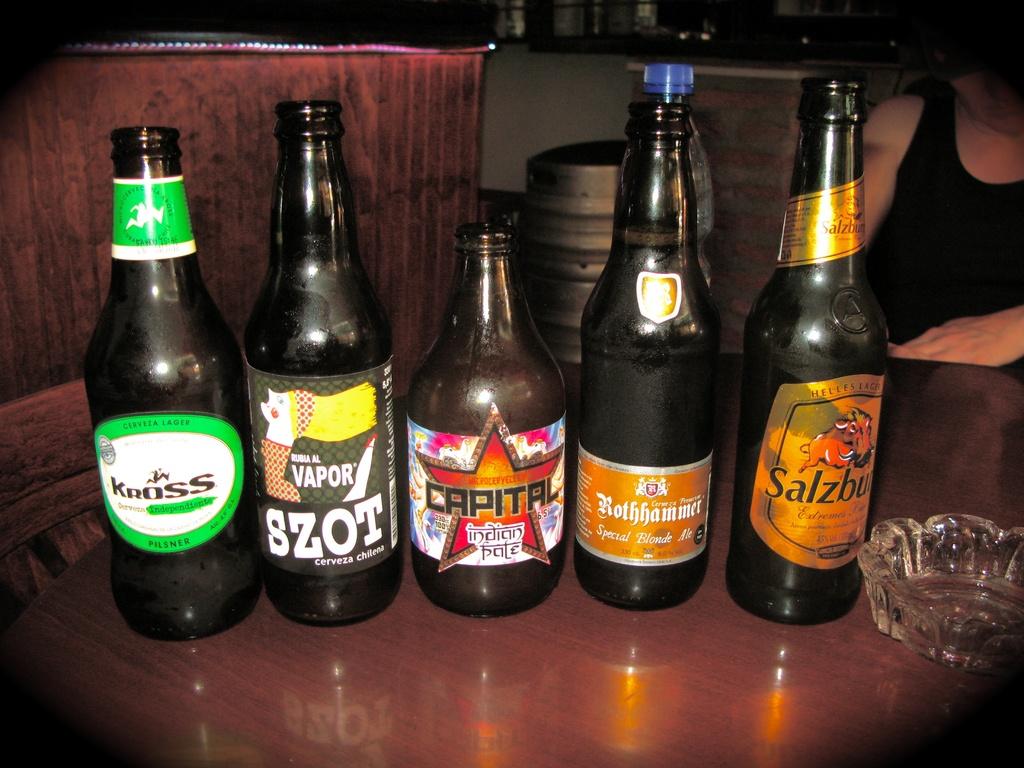What is written on the far left bottle?
Make the answer very short. Kross. 